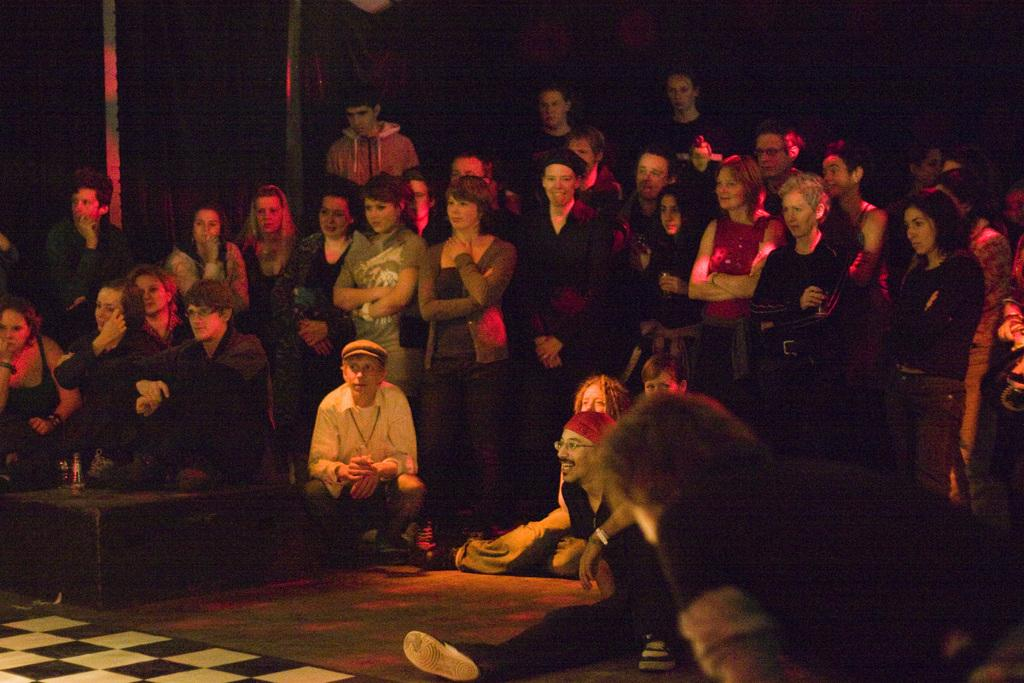How many people are in the image? There is a group of people in the image. What are the people in the image doing? Some people are sitting, while others are standing. What can be observed about the background of the image? The background of the image is dark. What type of plantation can be seen in the background of the image? There is no plantation present in the image; the background is dark. 